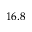Convert formula to latex. <formula><loc_0><loc_0><loc_500><loc_500>1 6 . 8</formula> 